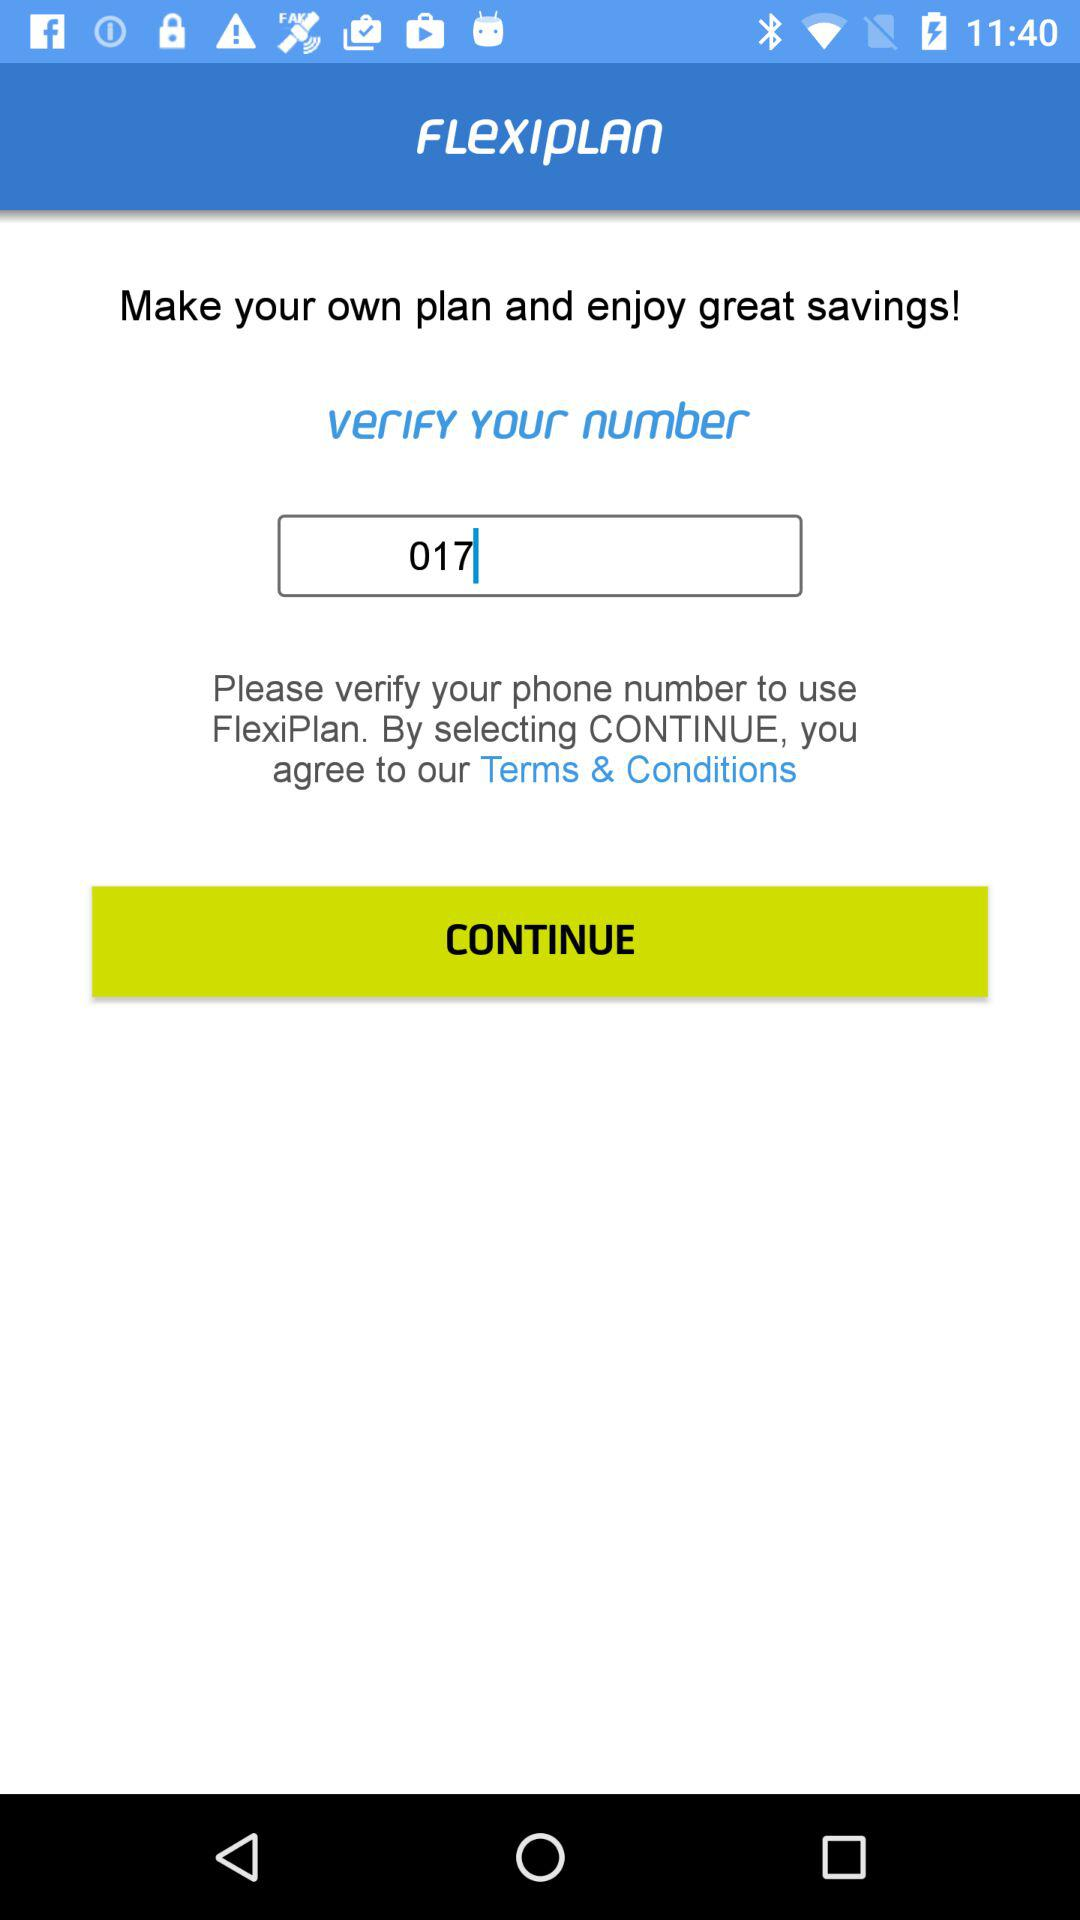What is the text written in the textfield? The text is 017. 